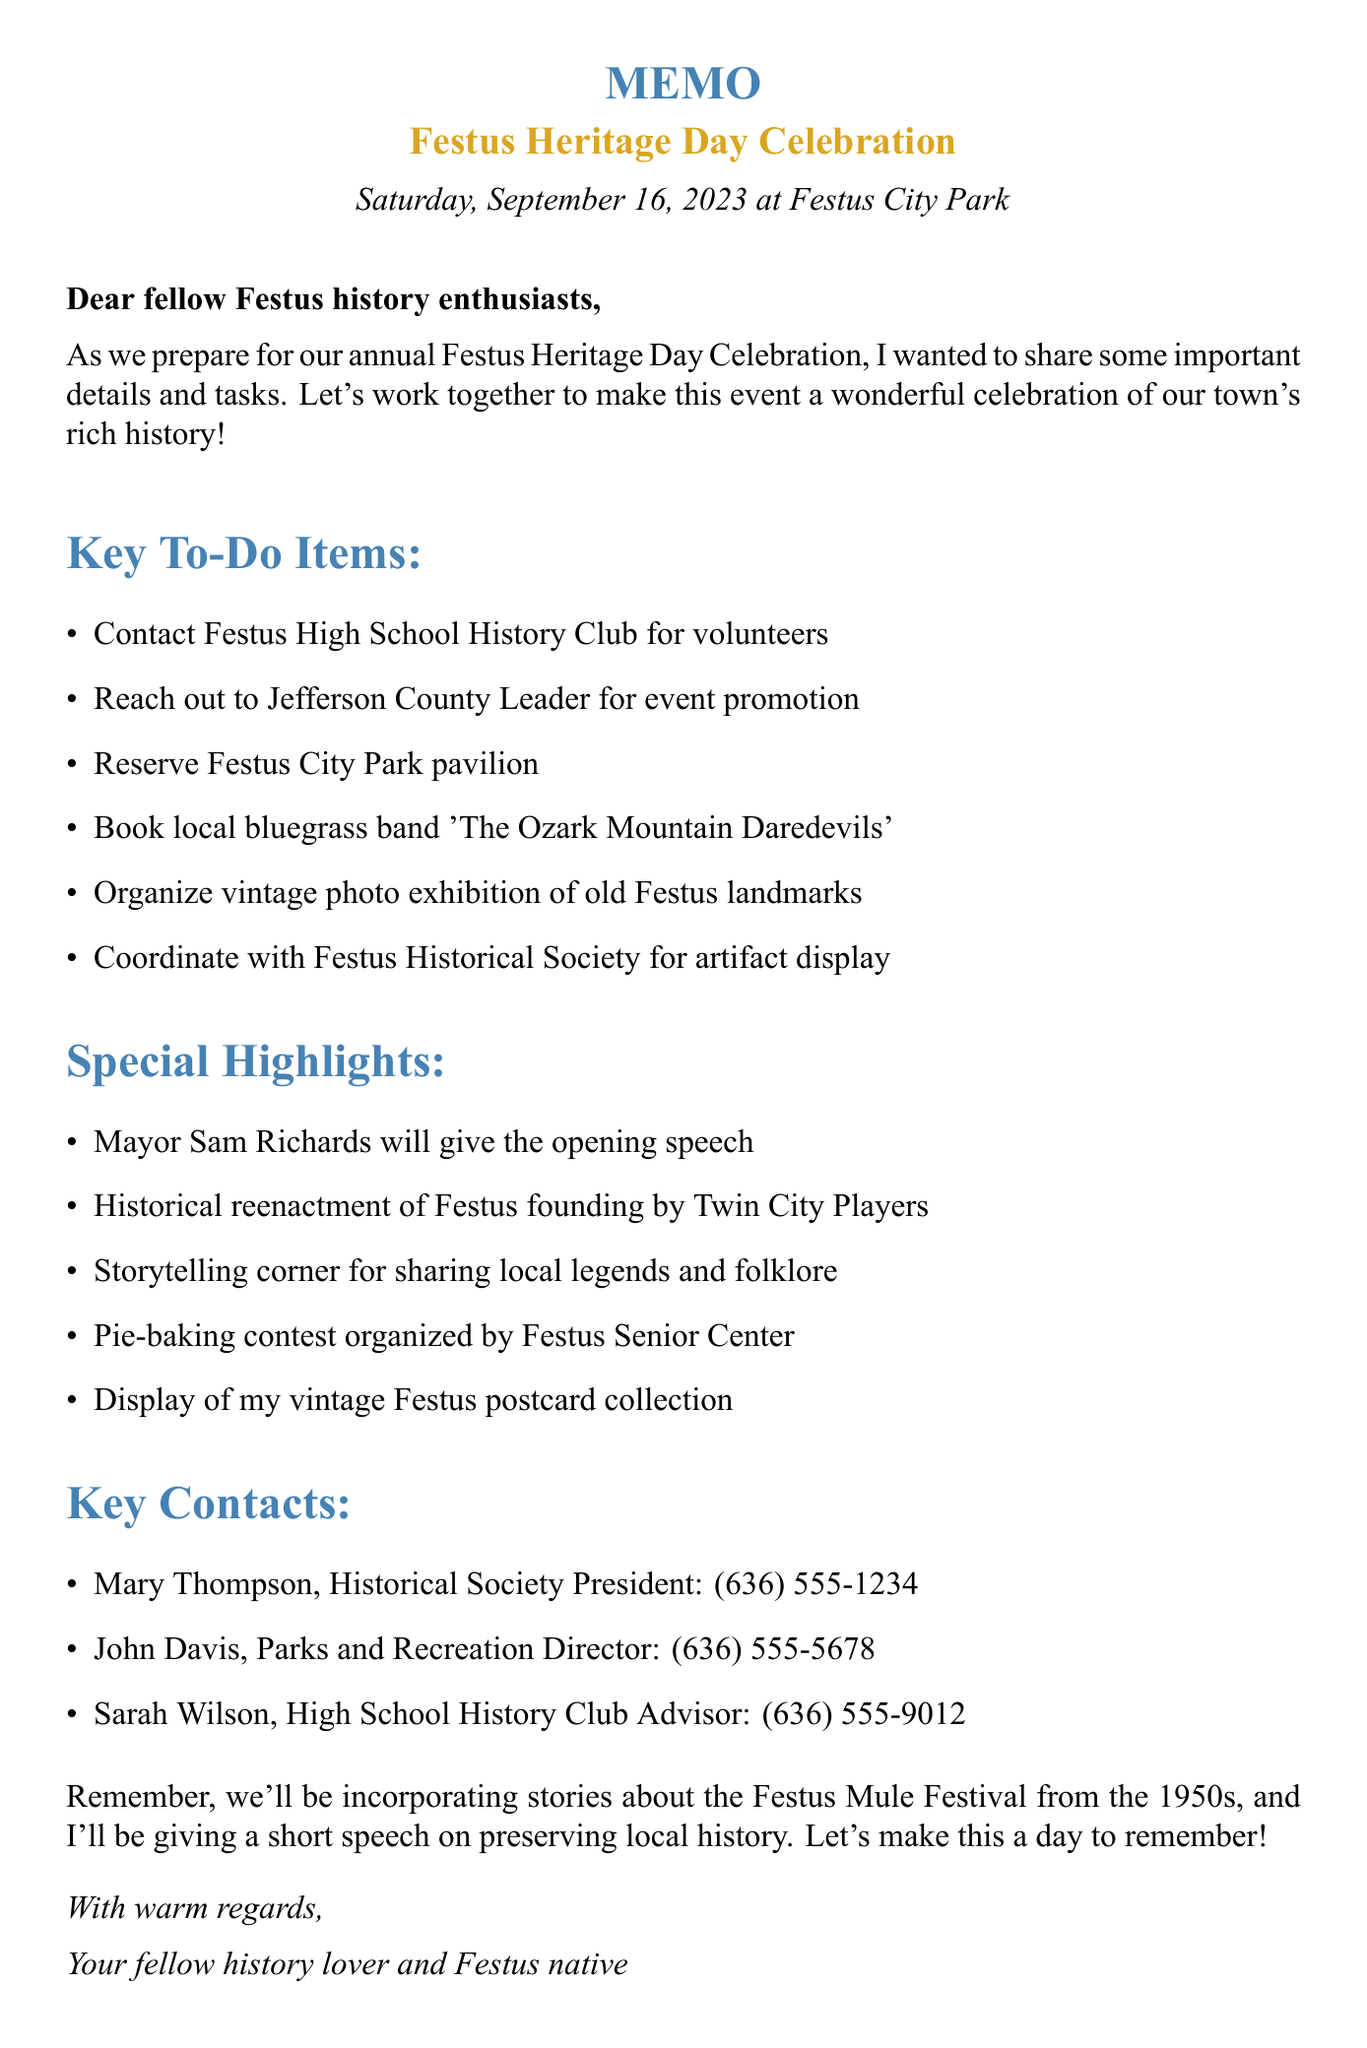what is the date of the Festus Heritage Day Celebration? The date is specifically mentioned in the document as the day of the event.
Answer: Saturday, September 16, 2023 where is the Festus Heritage Day Celebration held? The location is listed as the place where the event will take place.
Answer: Festus City Park who is the President of the Festus Historical Society? The document clearly specifies the name of the individual holding this title.
Answer: Mary Thompson what is one of the activities planned for children? The document outlines several activities for children and provides details about them.
Answer: old-fashioned games how will the event be promoted? The document specifies key tasks related to promoting the event involving external organizations.
Answer: Jefferson County Leader what kind of music will be featured at the event? The document lists the name of the band that will perform at the event.
Answer: bluegrass which group will organize the pie-baking contest? The document identifies the organization responsible for this specific activity.
Answer: Festus Senior Center what special speech will be given during the event? The document highlights what kind of speech will be given and by whom.
Answer: opening speech how will the event incorporate local history? The details in the document explain how history will be a part of the event's activities.
Answer: stories about the Festus Mule Festival from the 1950s 